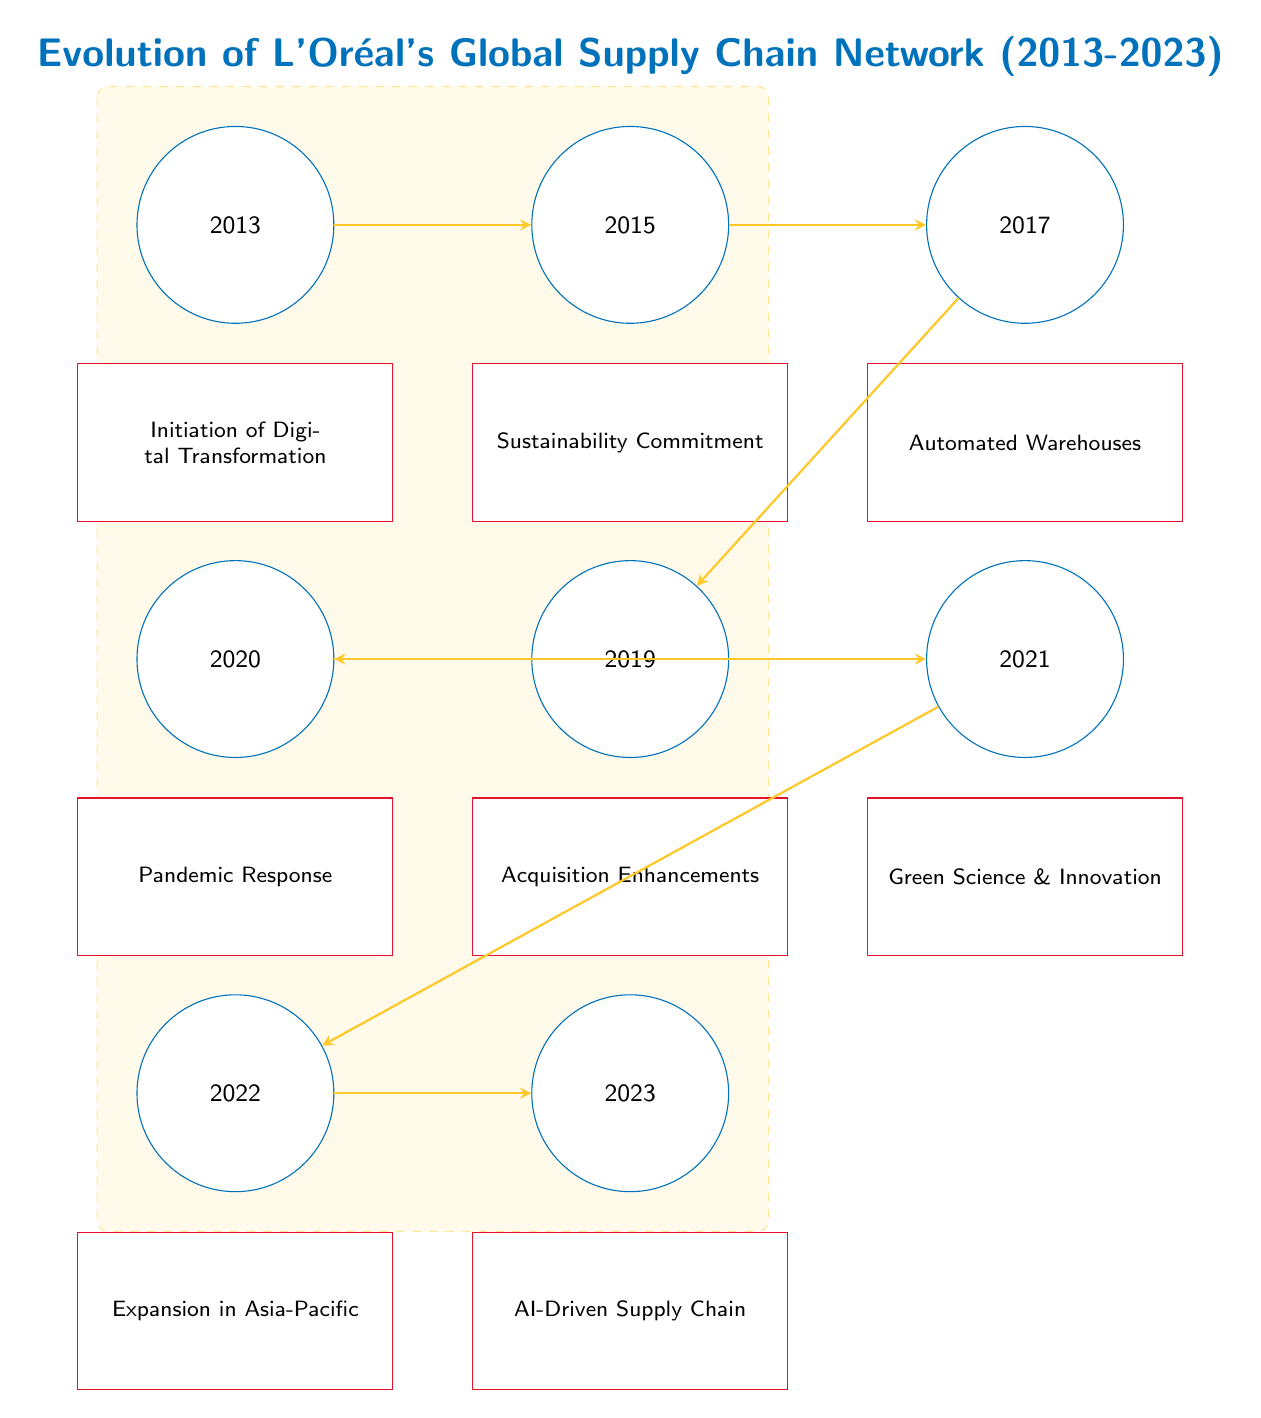What was the first major milestone in L'Oréal's supply chain evolution? According to the diagram, the first major milestone in 2013 is the "Initiation of Digital Transformation".
Answer: Initiation of Digital Transformation Which event occurred in 2015? The diagram indicates that in 2015, the event was the "Sustainability Commitment".
Answer: Sustainability Commitment How many major milestones are represented in the diagram? The diagram shows a total of 8 major milestones from 2013 to 2023.
Answer: 8 What event directly follows the "Automated Warehouses"? Looking at the diagram, the event that directly follows "Automated Warehouses" in 2017 is "Acquisition Enhancements" in 2019.
Answer: Acquisition Enhancements What are the last two events in the timeline? The last two events in the timeline are "Expansion in Asia-Pacific" in 2022 and "AI-Driven Supply Chain" in 2023.
Answer: Expansion in Asia-Pacific, AI-Driven Supply Chain Which event took place in 2020? According to the diagram, the event in 2020 is "Pandemic Response".
Answer: Pandemic Response What is the main focus of the supply chain evolution stated in 2021? The main focus of the supply chain evolution stated in 2021 is "Green Science & Innovation."
Answer: Green Science & Innovation How are the years connected in the evolution process? The years are connected through arrows indicating a sequential progression in the evolution of the supply chain network from one event to the next.
Answer: Through arrows What significant shift happened in L'Oréal's supply chain approach in 2023? The significant shift in 2023 involves the introduction of "AI-Driven Supply Chain".
Answer: AI-Driven Supply Chain 